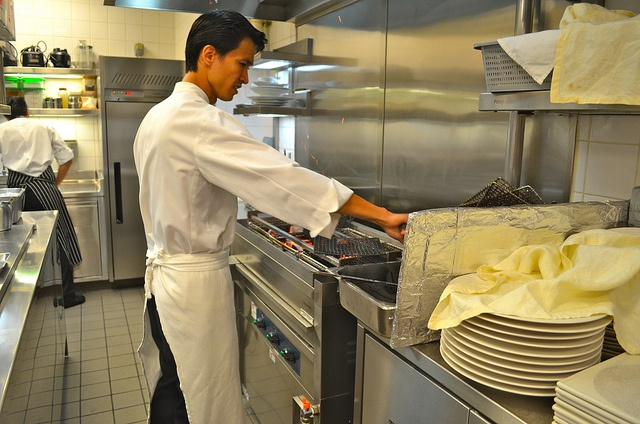Describe the objects in this image and their specific colors. I can see people in red, tan, and black tones, oven in red, gray, and black tones, refrigerator in red, gray, and black tones, people in red, black, tan, gray, and beige tones, and sink in red, black, and gray tones in this image. 